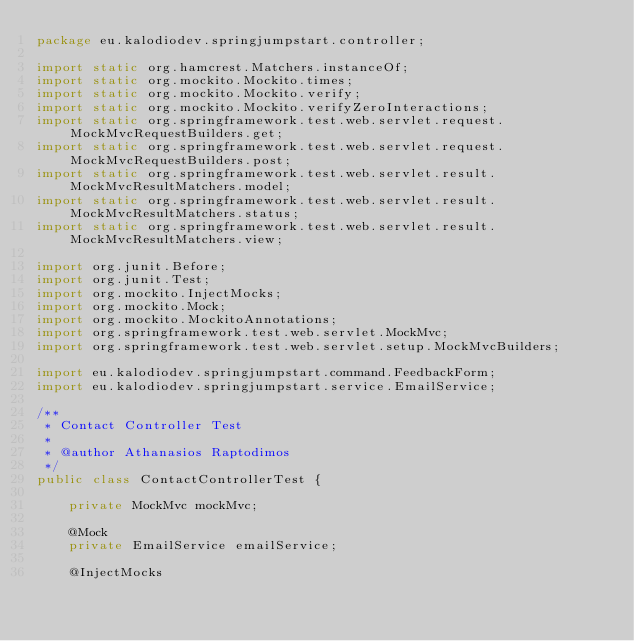<code> <loc_0><loc_0><loc_500><loc_500><_Java_>package eu.kalodiodev.springjumpstart.controller;

import static org.hamcrest.Matchers.instanceOf;
import static org.mockito.Mockito.times;
import static org.mockito.Mockito.verify;
import static org.mockito.Mockito.verifyZeroInteractions;
import static org.springframework.test.web.servlet.request.MockMvcRequestBuilders.get;
import static org.springframework.test.web.servlet.request.MockMvcRequestBuilders.post;
import static org.springframework.test.web.servlet.result.MockMvcResultMatchers.model;
import static org.springframework.test.web.servlet.result.MockMvcResultMatchers.status;
import static org.springframework.test.web.servlet.result.MockMvcResultMatchers.view;

import org.junit.Before;
import org.junit.Test;
import org.mockito.InjectMocks;
import org.mockito.Mock;
import org.mockito.MockitoAnnotations;
import org.springframework.test.web.servlet.MockMvc;
import org.springframework.test.web.servlet.setup.MockMvcBuilders;

import eu.kalodiodev.springjumpstart.command.FeedbackForm;
import eu.kalodiodev.springjumpstart.service.EmailService;

/**
 * Contact Controller Test
 *
 * @author Athanasios Raptodimos
 */
public class ContactControllerTest {
	
	private MockMvc mockMvc;
	
	@Mock
	private EmailService emailService;

	@InjectMocks</code> 